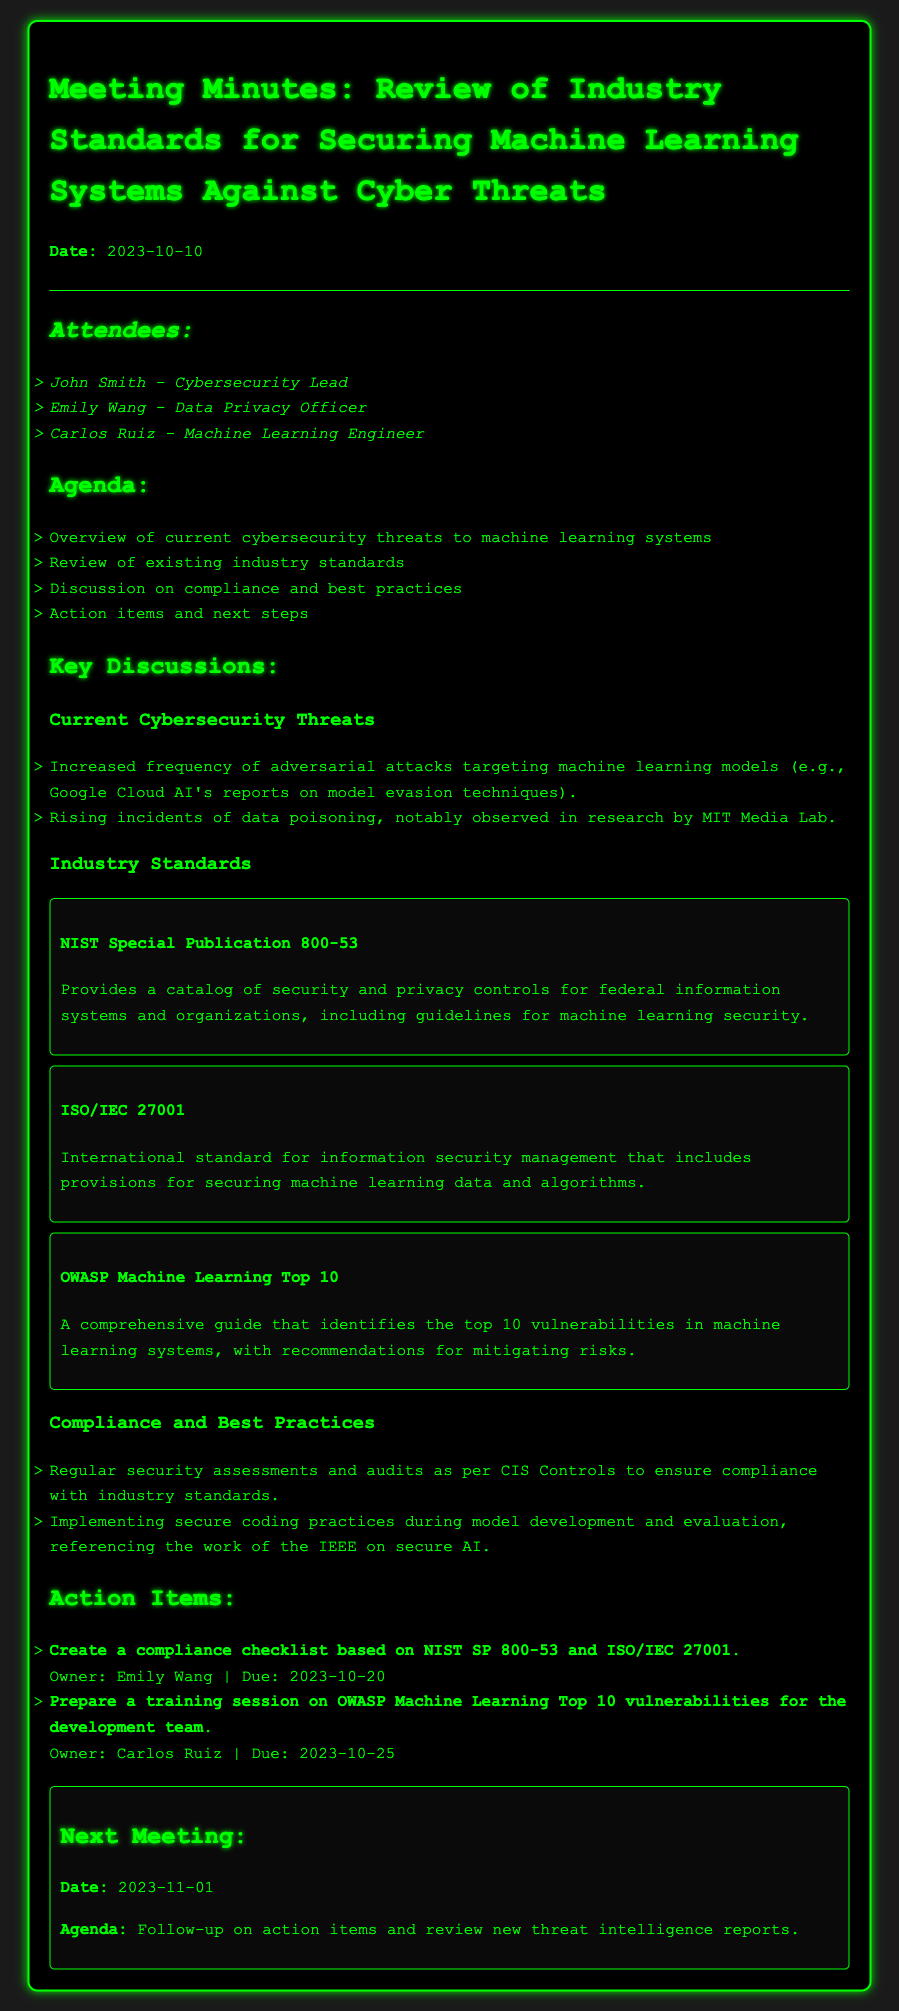What is the date of the meeting? The date of the meeting is explicitly mentioned in the header section of the document.
Answer: 2023-10-10 Who is the Cybersecurity Lead? The document lists attendees and their roles, clearly stating who holds each position.
Answer: John Smith Which standard provides a catalog of security and privacy controls? The document describes various industry standards and their purposes, including NIST Special Publication 800-53.
Answer: NIST Special Publication 800-53 What is the due date for creating a compliance checklist? Action items outline specific tasks with their respective owners and due dates.
Answer: 2023-10-20 How many attendees are listed in the document? The number of attendees is accounted for in the attendees section of the document.
Answer: 3 What is one vulnerability mentioned in the OWASP Machine Learning Top 10? The document refers to vulnerabilities but does not list them specifically; however, it acknowledges the existence of such vulnerabilities.
Answer: Top 10 vulnerabilities What action item is due on 2023-10-25? The action items section specifies tasks with due dates, indicating what is expected.
Answer: Prepare a training session on OWASP Machine Learning Top 10 vulnerabilities for the development team What is the agenda for the next meeting? The document includes a section dedicated to the next meeting, detailing what will be discussed.
Answer: Follow-up on action items and review new threat intelligence reports What research organization is mentioned regarding data poisoning? The document mentions different organizations involved in research on cybersecurity threats, which includes the source of information reported.
Answer: MIT Media Lab 